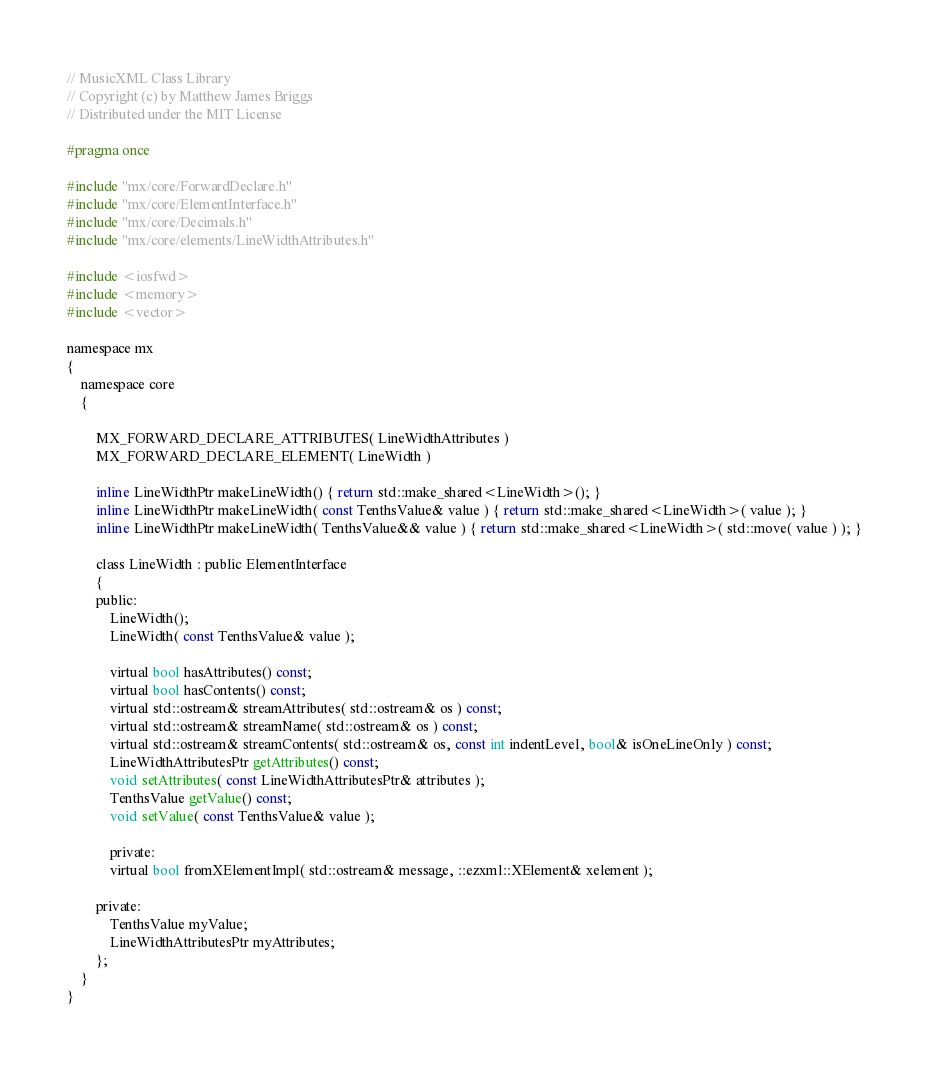<code> <loc_0><loc_0><loc_500><loc_500><_C_>// MusicXML Class Library
// Copyright (c) by Matthew James Briggs
// Distributed under the MIT License

#pragma once

#include "mx/core/ForwardDeclare.h"
#include "mx/core/ElementInterface.h"
#include "mx/core/Decimals.h"
#include "mx/core/elements/LineWidthAttributes.h"

#include <iosfwd>
#include <memory>
#include <vector>

namespace mx
{
    namespace core
    {

        MX_FORWARD_DECLARE_ATTRIBUTES( LineWidthAttributes )
        MX_FORWARD_DECLARE_ELEMENT( LineWidth )

        inline LineWidthPtr makeLineWidth() { return std::make_shared<LineWidth>(); }
		inline LineWidthPtr makeLineWidth( const TenthsValue& value ) { return std::make_shared<LineWidth>( value ); }
		inline LineWidthPtr makeLineWidth( TenthsValue&& value ) { return std::make_shared<LineWidth>( std::move( value ) ); }

        class LineWidth : public ElementInterface
        {
        public:
            LineWidth();
            LineWidth( const TenthsValue& value );

            virtual bool hasAttributes() const;
            virtual bool hasContents() const;
            virtual std::ostream& streamAttributes( std::ostream& os ) const;
            virtual std::ostream& streamName( std::ostream& os ) const;
            virtual std::ostream& streamContents( std::ostream& os, const int indentLevel, bool& isOneLineOnly ) const;
            LineWidthAttributesPtr getAttributes() const;
            void setAttributes( const LineWidthAttributesPtr& attributes );
            TenthsValue getValue() const;
            void setValue( const TenthsValue& value );

            private:
            virtual bool fromXElementImpl( std::ostream& message, ::ezxml::XElement& xelement );

        private:
            TenthsValue myValue;
            LineWidthAttributesPtr myAttributes;
        };
    }
}
</code> 